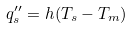Convert formula to latex. <formula><loc_0><loc_0><loc_500><loc_500>q _ { s } ^ { \prime \prime } = h ( T _ { s } - T _ { m } )</formula> 